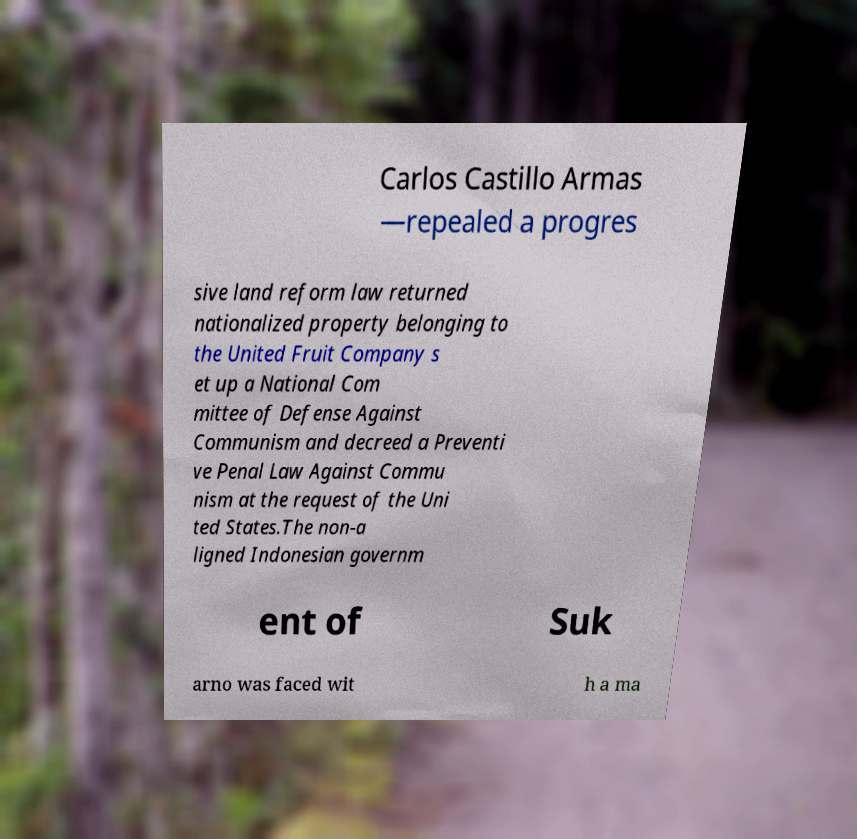For documentation purposes, I need the text within this image transcribed. Could you provide that? Carlos Castillo Armas —repealed a progres sive land reform law returned nationalized property belonging to the United Fruit Company s et up a National Com mittee of Defense Against Communism and decreed a Preventi ve Penal Law Against Commu nism at the request of the Uni ted States.The non-a ligned Indonesian governm ent of Suk arno was faced wit h a ma 